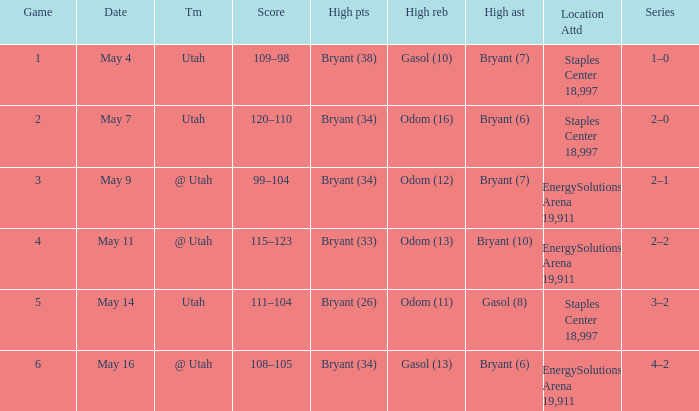What is the High rebounds with a Series with 4–2? Gasol (13). 